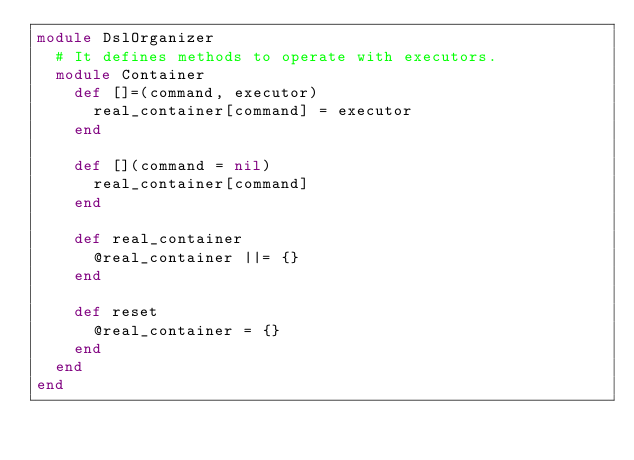<code> <loc_0><loc_0><loc_500><loc_500><_Ruby_>module DslOrganizer
  # It defines methods to operate with executors.
  module Container
    def []=(command, executor)
      real_container[command] = executor
    end

    def [](command = nil)
      real_container[command]
    end

    def real_container
      @real_container ||= {}
    end

    def reset
      @real_container = {}
    end
  end
end
</code> 